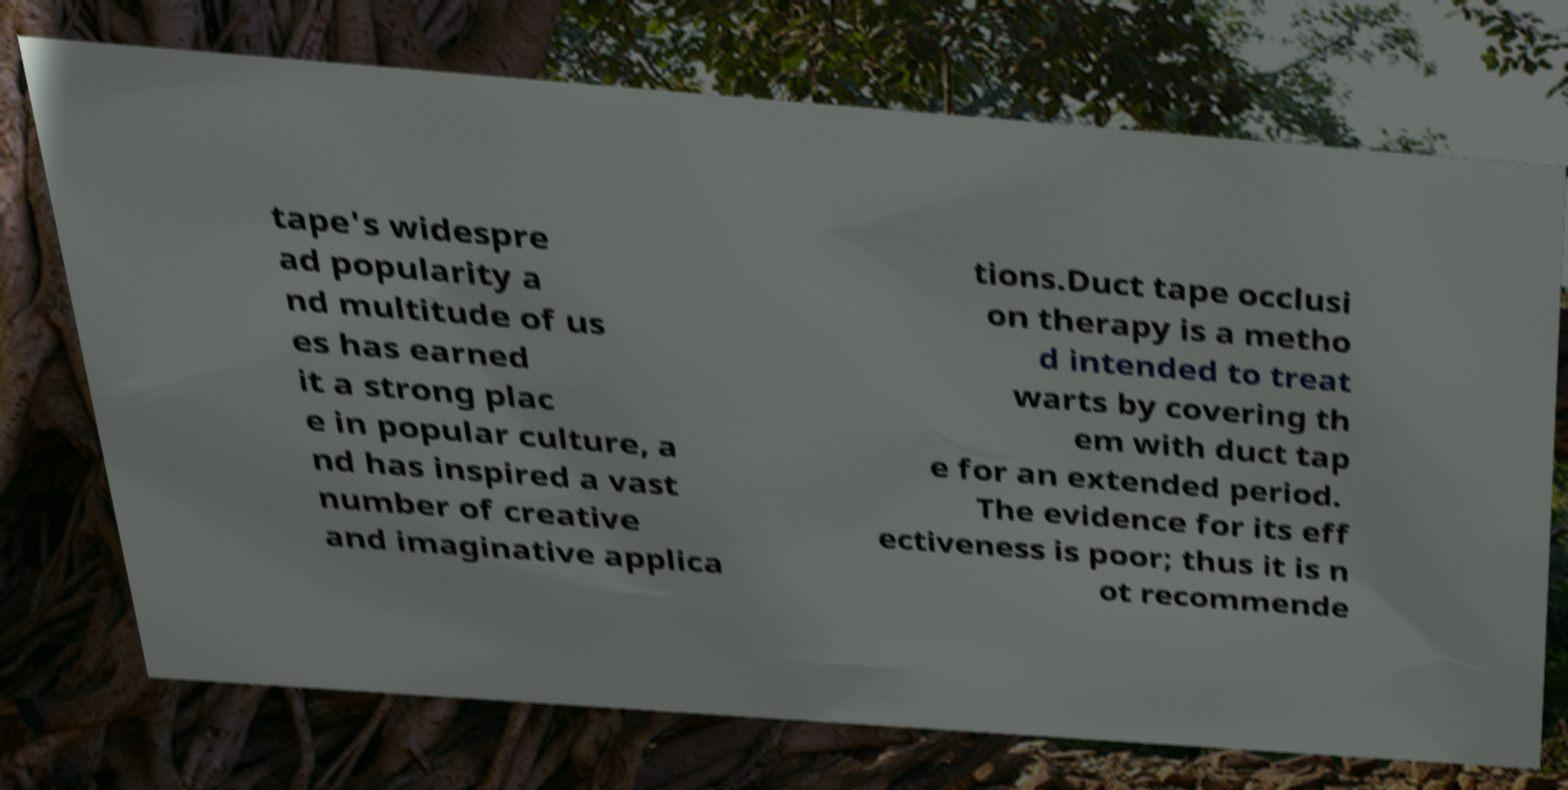I need the written content from this picture converted into text. Can you do that? tape's widespre ad popularity a nd multitude of us es has earned it a strong plac e in popular culture, a nd has inspired a vast number of creative and imaginative applica tions.Duct tape occlusi on therapy is a metho d intended to treat warts by covering th em with duct tap e for an extended period. The evidence for its eff ectiveness is poor; thus it is n ot recommende 